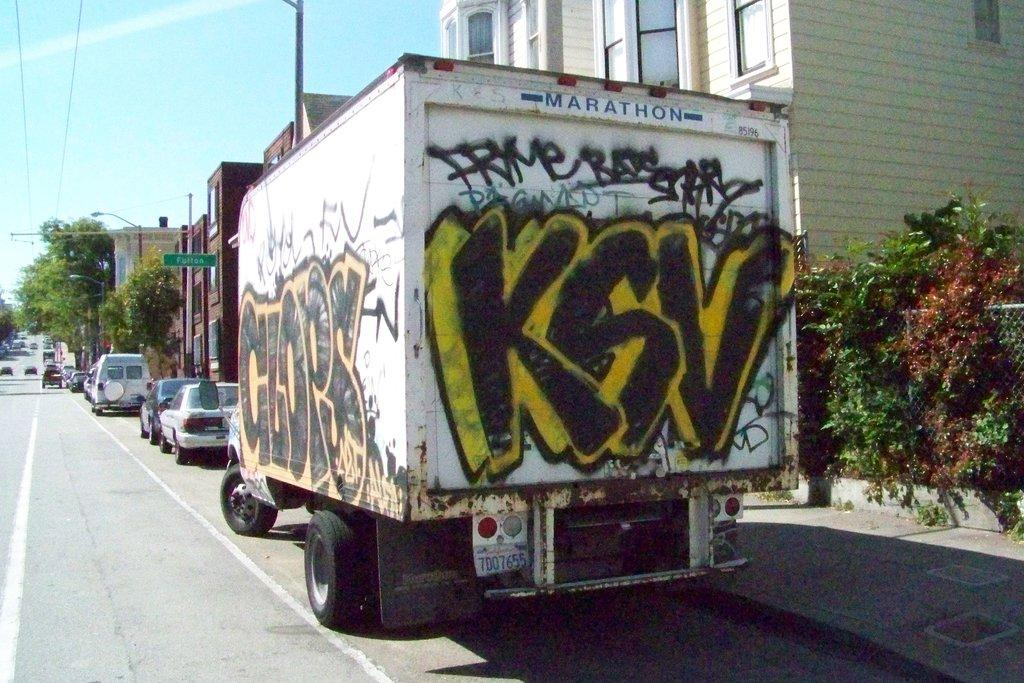What can be seen on the road in the image? There are vehicles on the road in the image. What type of vegetation is present in the image? There are plants and trees in the image. What structures can be seen in the image? There are poles, a board, and buildings in the image. What is visible in the background of the image? The sky is visible in the background of the image. How many flowers are present in the image? There are no flowers mentioned or visible in the image. What type of pleasure can be seen being experienced by the girls in the image? There are no girls present in the image, so it is not possible to determine what type of pleasure they might be experiencing. 